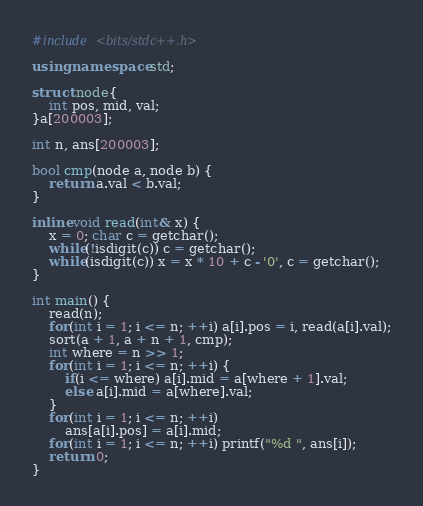<code> <loc_0><loc_0><loc_500><loc_500><_C++_>#include <bits/stdc++.h>

using namespace std;

struct node{
	int pos, mid, val;
}a[200003];

int n, ans[200003];

bool cmp(node a, node b) {
	return a.val < b.val;
}

inline void read(int& x) {
	x = 0; char c = getchar();
	while(!isdigit(c)) c = getchar();
	while(isdigit(c)) x = x * 10 + c - '0', c = getchar();
}

int main() {
	read(n);
	for(int i = 1; i <= n; ++i) a[i].pos = i, read(a[i].val);
	sort(a + 1, a + n + 1, cmp);
	int where = n >> 1;
	for(int i = 1; i <= n; ++i) {
		if(i <= where) a[i].mid = a[where + 1].val;
		else a[i].mid = a[where].val;  
	}
	for(int i = 1; i <= n; ++i)
		ans[a[i].pos] = a[i].mid;
	for(int i = 1; i <= n; ++i) printf("%d ", ans[i]);
	return 0;
}</code> 